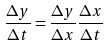<formula> <loc_0><loc_0><loc_500><loc_500>\frac { \Delta y } { \Delta t } = \frac { \Delta y } { \Delta x } \frac { \Delta x } { \Delta t }</formula> 